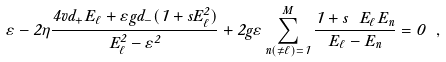<formula> <loc_0><loc_0><loc_500><loc_500>\varepsilon - 2 \eta \frac { 4 v d _ { + } { E } _ { \ell } + \varepsilon g d _ { - } ( 1 + s E _ { \ell } ^ { 2 } ) } { { E } _ { \ell } ^ { 2 } - \varepsilon ^ { 2 } } + 2 g \varepsilon \sum _ { n \left ( \neq \ell \right ) = 1 } ^ { M } \frac { 1 + s \ { E } _ { \ell } { E } _ { n } } { { E } _ { \ell } - { E } _ { n } } = 0 \ ,</formula> 